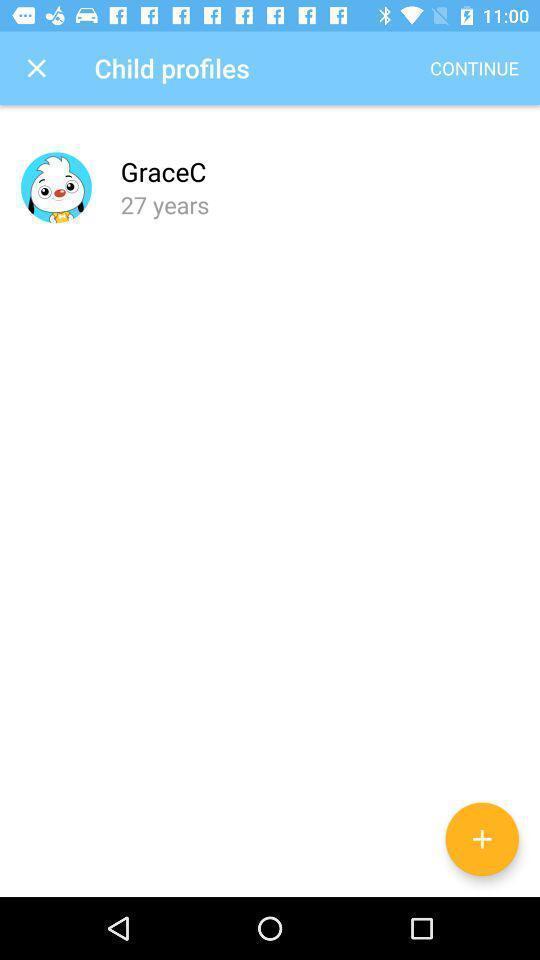Give me a narrative description of this picture. Screen displaying contents in profile page. 